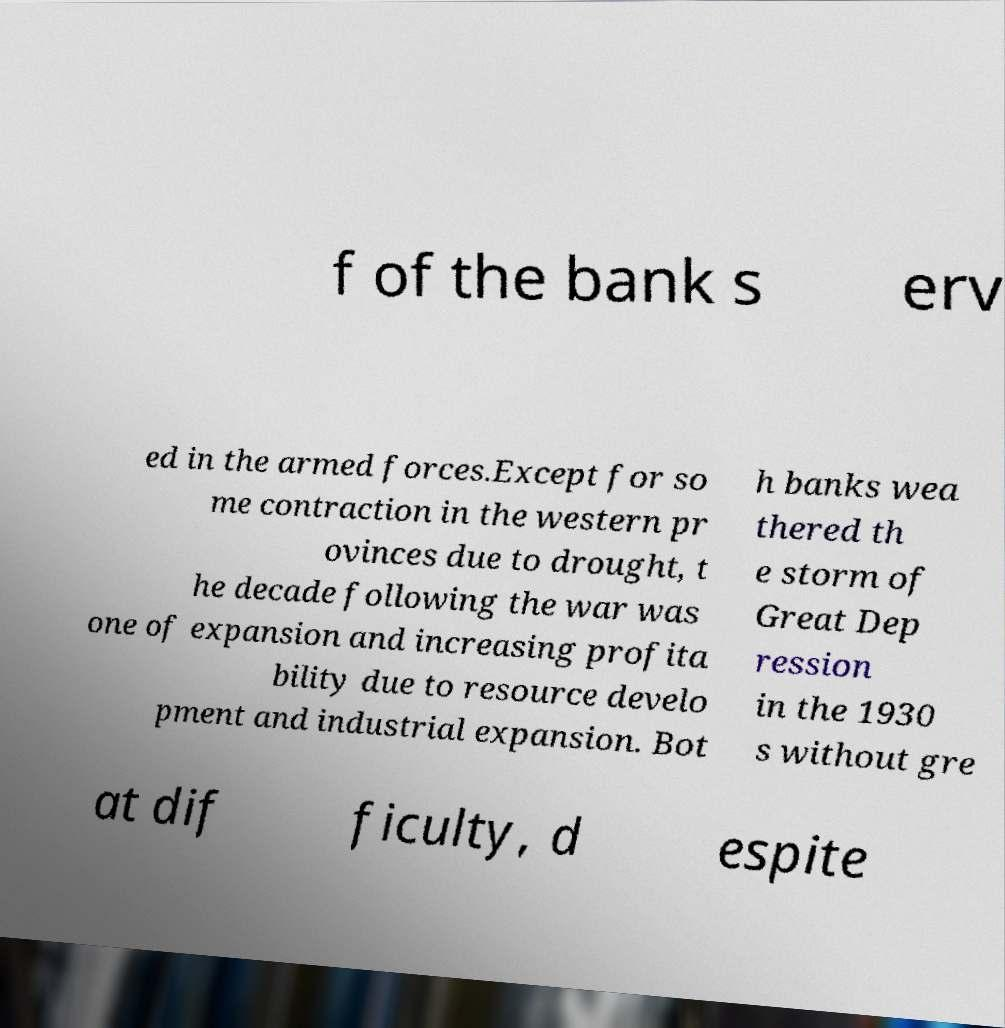There's text embedded in this image that I need extracted. Can you transcribe it verbatim? f of the bank s erv ed in the armed forces.Except for so me contraction in the western pr ovinces due to drought, t he decade following the war was one of expansion and increasing profita bility due to resource develo pment and industrial expansion. Bot h banks wea thered th e storm of Great Dep ression in the 1930 s without gre at dif ficulty, d espite 